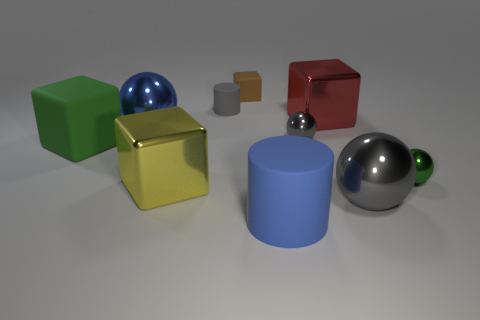How many other matte cubes have the same color as the small matte block?
Provide a short and direct response. 0. What size is the brown rubber cube?
Provide a succinct answer. Small. Does the yellow block have the same size as the blue shiny object?
Offer a terse response. Yes. What color is the tiny object that is both behind the big red block and on the right side of the gray matte cylinder?
Provide a short and direct response. Brown. How many blocks are the same material as the large yellow thing?
Provide a succinct answer. 1. What number of large matte things are there?
Offer a very short reply. 2. There is a red block; does it have the same size as the shiny cube left of the big cylinder?
Ensure brevity in your answer.  Yes. What material is the cube that is right of the object that is in front of the big gray object?
Give a very brief answer. Metal. What size is the blue object behind the gray thing that is in front of the large shiny cube that is left of the blue cylinder?
Give a very brief answer. Large. There is a blue matte object; does it have the same shape as the metal object to the left of the yellow shiny block?
Your response must be concise. No. 